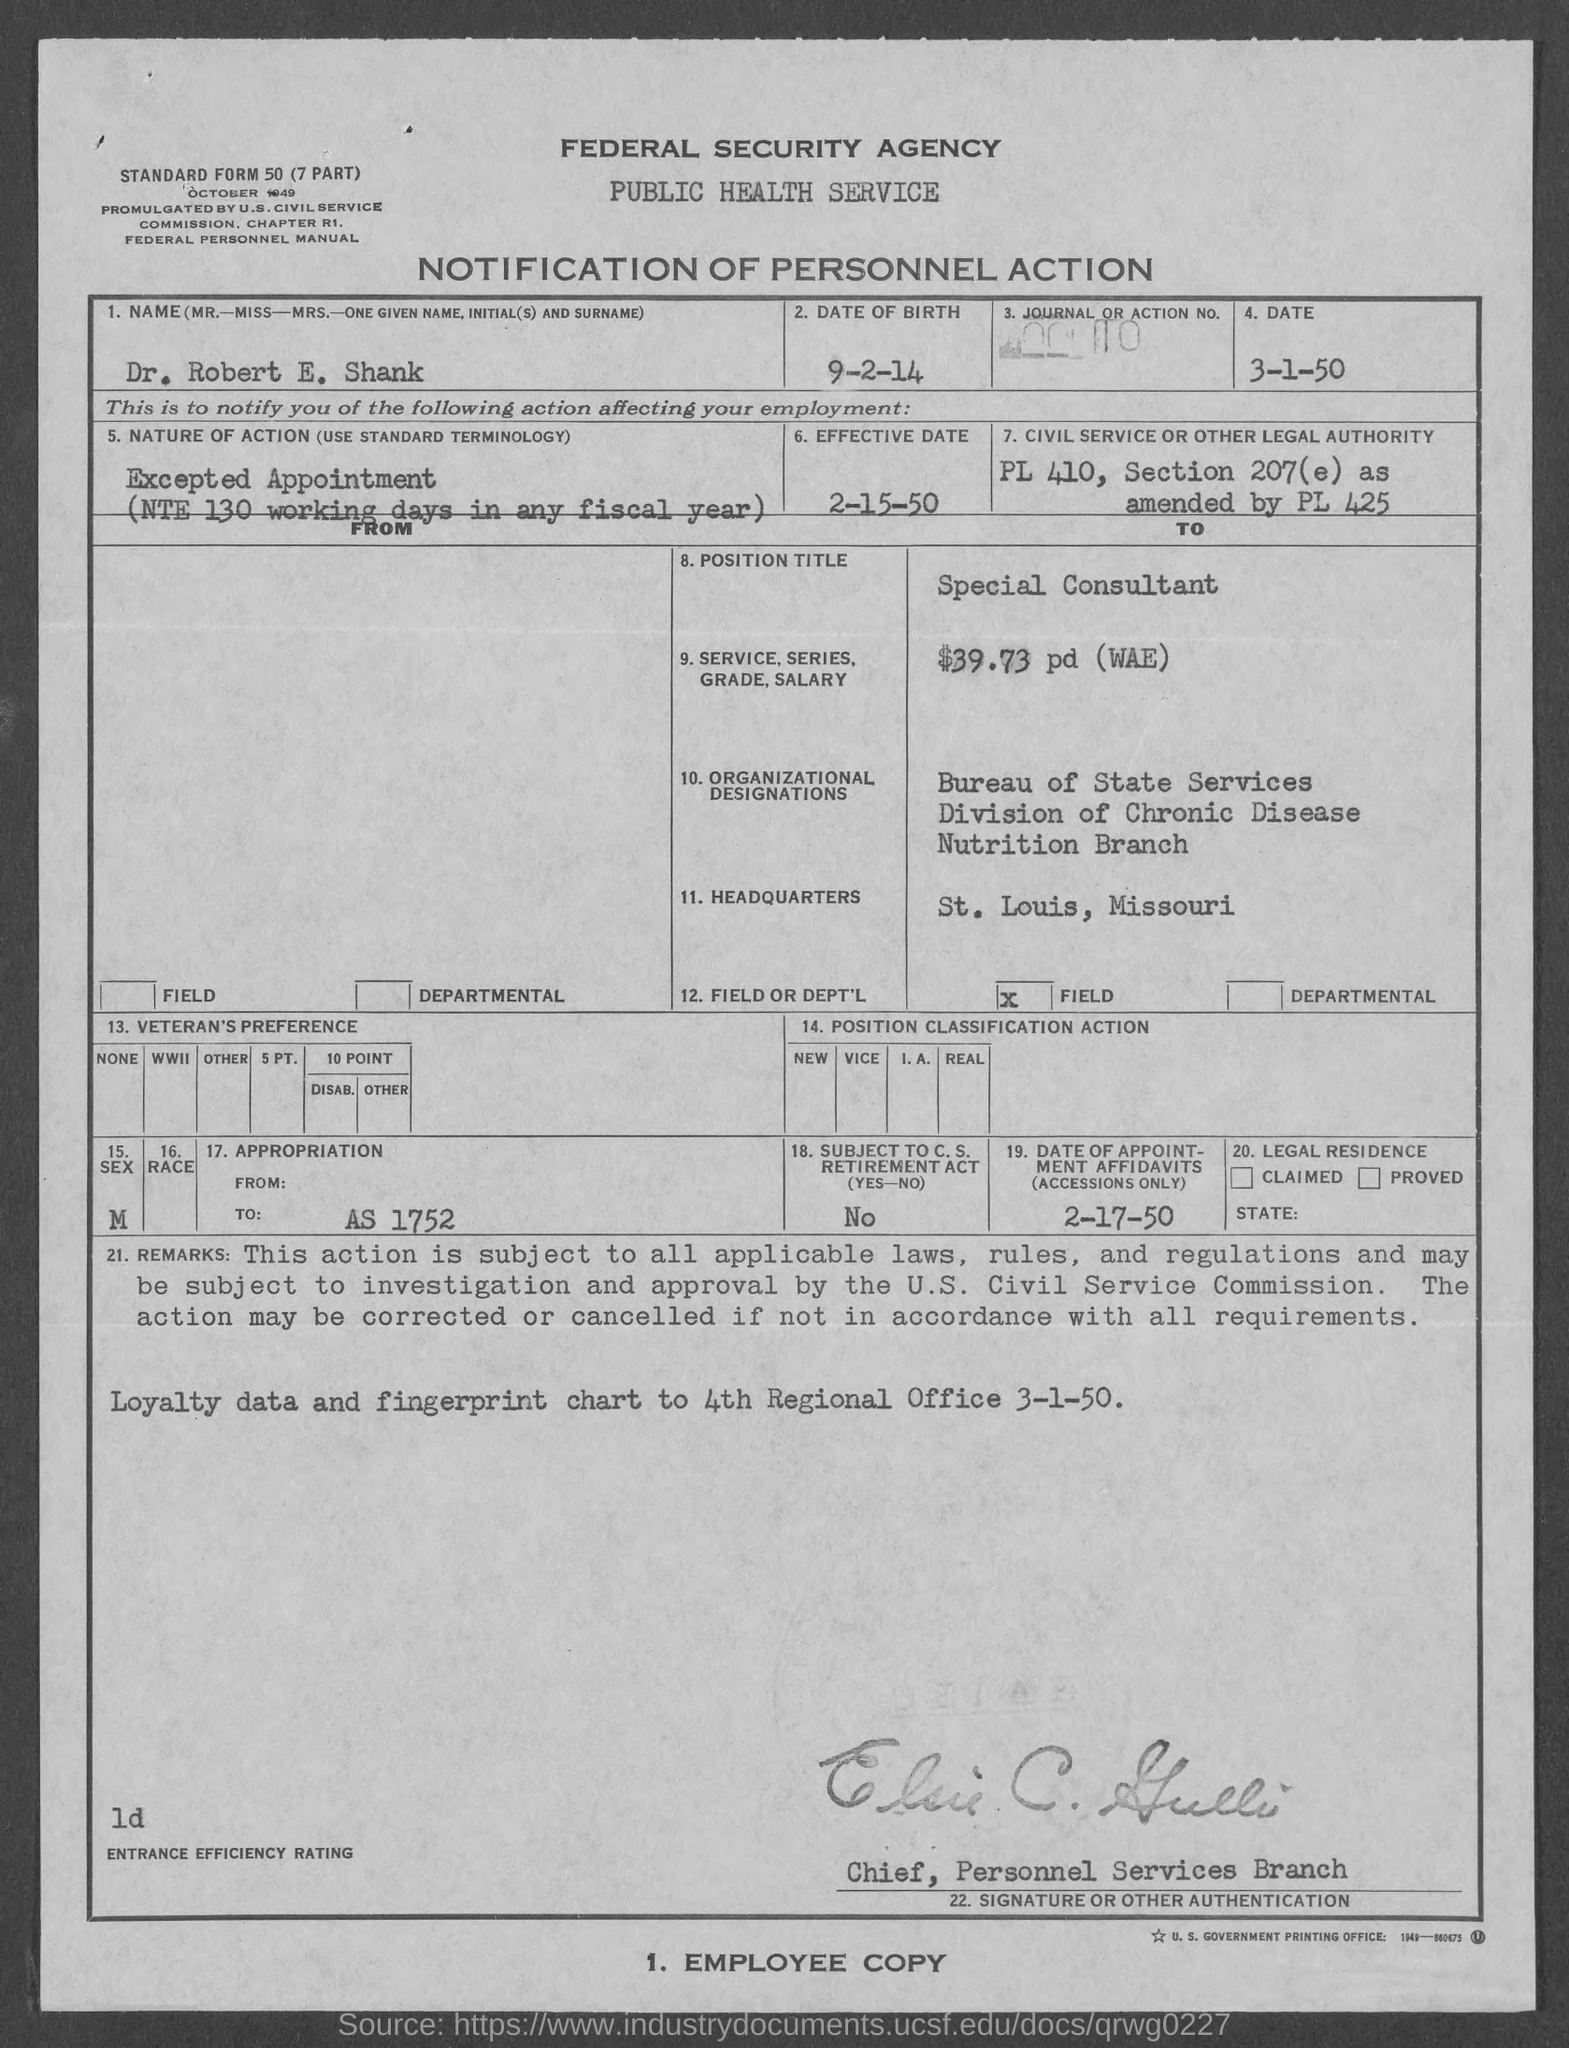Identify some key points in this picture. The headquarters is located in St. Louis, Missouri. What is the date? March 1, 1950. Dr. Robert E. Shank's name is the name. The effective date of the document is February 15, 1950. The date of the appointment affidavit is February 17, 1950. 